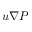<formula> <loc_0><loc_0><loc_500><loc_500>u \nabla P</formula> 